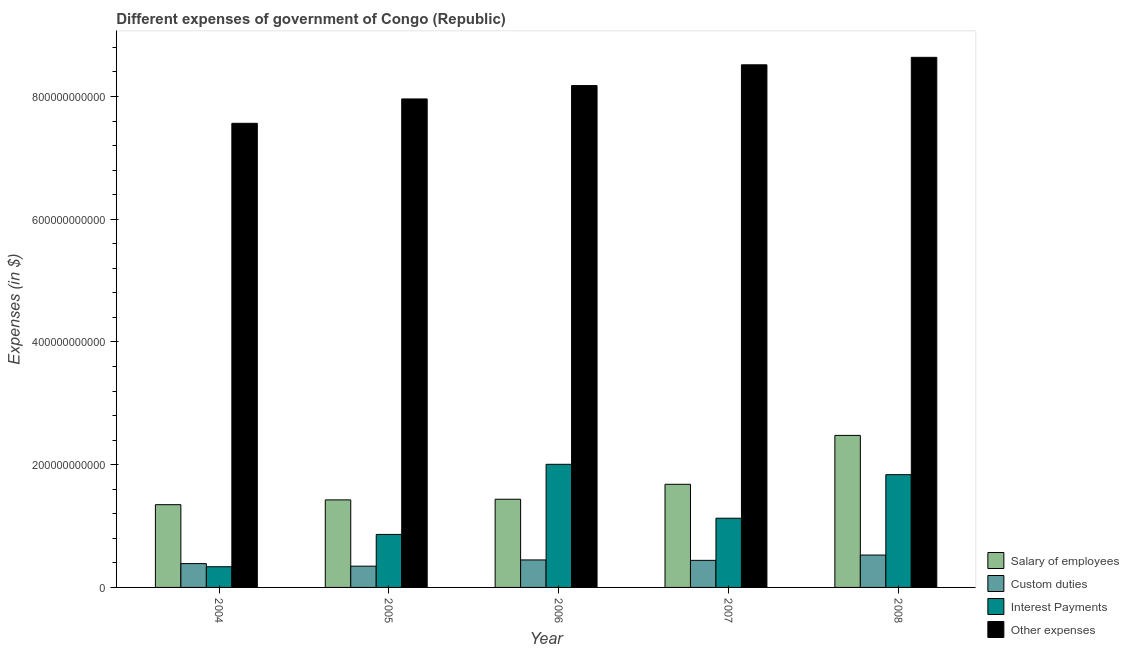How many different coloured bars are there?
Keep it short and to the point. 4. Are the number of bars on each tick of the X-axis equal?
Provide a short and direct response. Yes. How many bars are there on the 1st tick from the right?
Offer a very short reply. 4. In how many cases, is the number of bars for a given year not equal to the number of legend labels?
Offer a terse response. 0. What is the amount spent on interest payments in 2005?
Your answer should be compact. 8.64e+1. Across all years, what is the maximum amount spent on salary of employees?
Offer a very short reply. 2.48e+11. Across all years, what is the minimum amount spent on other expenses?
Your answer should be compact. 7.56e+11. What is the total amount spent on salary of employees in the graph?
Ensure brevity in your answer.  8.37e+11. What is the difference between the amount spent on interest payments in 2004 and that in 2008?
Your answer should be very brief. -1.50e+11. What is the difference between the amount spent on custom duties in 2004 and the amount spent on interest payments in 2007?
Make the answer very short. -5.30e+09. What is the average amount spent on salary of employees per year?
Your answer should be very brief. 1.67e+11. In the year 2008, what is the difference between the amount spent on salary of employees and amount spent on interest payments?
Make the answer very short. 0. In how many years, is the amount spent on custom duties greater than 480000000000 $?
Provide a short and direct response. 0. What is the ratio of the amount spent on interest payments in 2004 to that in 2006?
Provide a succinct answer. 0.17. Is the amount spent on salary of employees in 2005 less than that in 2008?
Your answer should be very brief. Yes. What is the difference between the highest and the second highest amount spent on interest payments?
Provide a succinct answer. 1.69e+1. What is the difference between the highest and the lowest amount spent on salary of employees?
Give a very brief answer. 1.13e+11. In how many years, is the amount spent on other expenses greater than the average amount spent on other expenses taken over all years?
Make the answer very short. 3. Is the sum of the amount spent on other expenses in 2004 and 2008 greater than the maximum amount spent on salary of employees across all years?
Keep it short and to the point. Yes. What does the 2nd bar from the left in 2007 represents?
Your answer should be very brief. Custom duties. What does the 4th bar from the right in 2007 represents?
Your answer should be compact. Salary of employees. How many bars are there?
Your answer should be compact. 20. Are all the bars in the graph horizontal?
Provide a short and direct response. No. How many years are there in the graph?
Keep it short and to the point. 5. What is the difference between two consecutive major ticks on the Y-axis?
Keep it short and to the point. 2.00e+11. Are the values on the major ticks of Y-axis written in scientific E-notation?
Make the answer very short. No. Does the graph contain any zero values?
Provide a short and direct response. No. Does the graph contain grids?
Give a very brief answer. No. How are the legend labels stacked?
Your answer should be very brief. Vertical. What is the title of the graph?
Make the answer very short. Different expenses of government of Congo (Republic). Does "Structural Policies" appear as one of the legend labels in the graph?
Make the answer very short. No. What is the label or title of the Y-axis?
Your response must be concise. Expenses (in $). What is the Expenses (in $) in Salary of employees in 2004?
Your answer should be very brief. 1.35e+11. What is the Expenses (in $) in Custom duties in 2004?
Provide a short and direct response. 3.88e+1. What is the Expenses (in $) in Interest Payments in 2004?
Keep it short and to the point. 3.37e+1. What is the Expenses (in $) of Other expenses in 2004?
Give a very brief answer. 7.56e+11. What is the Expenses (in $) in Salary of employees in 2005?
Ensure brevity in your answer.  1.43e+11. What is the Expenses (in $) in Custom duties in 2005?
Your answer should be compact. 3.46e+1. What is the Expenses (in $) of Interest Payments in 2005?
Provide a short and direct response. 8.64e+1. What is the Expenses (in $) of Other expenses in 2005?
Ensure brevity in your answer.  7.96e+11. What is the Expenses (in $) in Salary of employees in 2006?
Make the answer very short. 1.44e+11. What is the Expenses (in $) of Custom duties in 2006?
Keep it short and to the point. 4.48e+1. What is the Expenses (in $) in Interest Payments in 2006?
Offer a very short reply. 2.01e+11. What is the Expenses (in $) in Other expenses in 2006?
Your answer should be compact. 8.18e+11. What is the Expenses (in $) in Salary of employees in 2007?
Ensure brevity in your answer.  1.68e+11. What is the Expenses (in $) of Custom duties in 2007?
Provide a succinct answer. 4.41e+1. What is the Expenses (in $) in Interest Payments in 2007?
Offer a very short reply. 1.13e+11. What is the Expenses (in $) in Other expenses in 2007?
Give a very brief answer. 8.52e+11. What is the Expenses (in $) in Salary of employees in 2008?
Ensure brevity in your answer.  2.48e+11. What is the Expenses (in $) of Custom duties in 2008?
Offer a very short reply. 5.27e+1. What is the Expenses (in $) in Interest Payments in 2008?
Provide a succinct answer. 1.84e+11. What is the Expenses (in $) of Other expenses in 2008?
Offer a very short reply. 8.64e+11. Across all years, what is the maximum Expenses (in $) of Salary of employees?
Provide a succinct answer. 2.48e+11. Across all years, what is the maximum Expenses (in $) of Custom duties?
Your answer should be compact. 5.27e+1. Across all years, what is the maximum Expenses (in $) in Interest Payments?
Make the answer very short. 2.01e+11. Across all years, what is the maximum Expenses (in $) in Other expenses?
Make the answer very short. 8.64e+11. Across all years, what is the minimum Expenses (in $) in Salary of employees?
Keep it short and to the point. 1.35e+11. Across all years, what is the minimum Expenses (in $) in Custom duties?
Provide a succinct answer. 3.46e+1. Across all years, what is the minimum Expenses (in $) of Interest Payments?
Offer a very short reply. 3.37e+1. Across all years, what is the minimum Expenses (in $) of Other expenses?
Keep it short and to the point. 7.56e+11. What is the total Expenses (in $) in Salary of employees in the graph?
Ensure brevity in your answer.  8.37e+11. What is the total Expenses (in $) of Custom duties in the graph?
Your answer should be very brief. 2.15e+11. What is the total Expenses (in $) of Interest Payments in the graph?
Keep it short and to the point. 6.17e+11. What is the total Expenses (in $) of Other expenses in the graph?
Your answer should be very brief. 4.09e+12. What is the difference between the Expenses (in $) in Salary of employees in 2004 and that in 2005?
Offer a very short reply. -7.81e+09. What is the difference between the Expenses (in $) of Custom duties in 2004 and that in 2005?
Provide a short and direct response. 4.19e+09. What is the difference between the Expenses (in $) in Interest Payments in 2004 and that in 2005?
Your response must be concise. -5.27e+1. What is the difference between the Expenses (in $) in Other expenses in 2004 and that in 2005?
Offer a terse response. -3.97e+1. What is the difference between the Expenses (in $) in Salary of employees in 2004 and that in 2006?
Offer a terse response. -8.86e+09. What is the difference between the Expenses (in $) of Custom duties in 2004 and that in 2006?
Offer a terse response. -5.97e+09. What is the difference between the Expenses (in $) in Interest Payments in 2004 and that in 2006?
Your response must be concise. -1.67e+11. What is the difference between the Expenses (in $) of Other expenses in 2004 and that in 2006?
Your response must be concise. -6.15e+1. What is the difference between the Expenses (in $) in Salary of employees in 2004 and that in 2007?
Offer a very short reply. -3.32e+1. What is the difference between the Expenses (in $) of Custom duties in 2004 and that in 2007?
Your answer should be very brief. -5.30e+09. What is the difference between the Expenses (in $) of Interest Payments in 2004 and that in 2007?
Your answer should be compact. -7.90e+1. What is the difference between the Expenses (in $) of Other expenses in 2004 and that in 2007?
Provide a short and direct response. -9.53e+1. What is the difference between the Expenses (in $) in Salary of employees in 2004 and that in 2008?
Your answer should be very brief. -1.13e+11. What is the difference between the Expenses (in $) of Custom duties in 2004 and that in 2008?
Ensure brevity in your answer.  -1.39e+1. What is the difference between the Expenses (in $) in Interest Payments in 2004 and that in 2008?
Your answer should be very brief. -1.50e+11. What is the difference between the Expenses (in $) of Other expenses in 2004 and that in 2008?
Keep it short and to the point. -1.08e+11. What is the difference between the Expenses (in $) in Salary of employees in 2005 and that in 2006?
Keep it short and to the point. -1.05e+09. What is the difference between the Expenses (in $) in Custom duties in 2005 and that in 2006?
Give a very brief answer. -1.02e+1. What is the difference between the Expenses (in $) in Interest Payments in 2005 and that in 2006?
Make the answer very short. -1.14e+11. What is the difference between the Expenses (in $) of Other expenses in 2005 and that in 2006?
Give a very brief answer. -2.18e+1. What is the difference between the Expenses (in $) in Salary of employees in 2005 and that in 2007?
Provide a succinct answer. -2.54e+1. What is the difference between the Expenses (in $) of Custom duties in 2005 and that in 2007?
Give a very brief answer. -9.48e+09. What is the difference between the Expenses (in $) in Interest Payments in 2005 and that in 2007?
Make the answer very short. -2.64e+1. What is the difference between the Expenses (in $) in Other expenses in 2005 and that in 2007?
Offer a very short reply. -5.56e+1. What is the difference between the Expenses (in $) in Salary of employees in 2005 and that in 2008?
Give a very brief answer. -1.05e+11. What is the difference between the Expenses (in $) of Custom duties in 2005 and that in 2008?
Ensure brevity in your answer.  -1.81e+1. What is the difference between the Expenses (in $) in Interest Payments in 2005 and that in 2008?
Provide a succinct answer. -9.73e+1. What is the difference between the Expenses (in $) of Other expenses in 2005 and that in 2008?
Ensure brevity in your answer.  -6.78e+1. What is the difference between the Expenses (in $) of Salary of employees in 2006 and that in 2007?
Ensure brevity in your answer.  -2.43e+1. What is the difference between the Expenses (in $) of Custom duties in 2006 and that in 2007?
Ensure brevity in your answer.  6.73e+08. What is the difference between the Expenses (in $) of Interest Payments in 2006 and that in 2007?
Provide a succinct answer. 8.79e+1. What is the difference between the Expenses (in $) of Other expenses in 2006 and that in 2007?
Make the answer very short. -3.38e+1. What is the difference between the Expenses (in $) in Salary of employees in 2006 and that in 2008?
Your answer should be very brief. -1.04e+11. What is the difference between the Expenses (in $) of Custom duties in 2006 and that in 2008?
Offer a very short reply. -7.95e+09. What is the difference between the Expenses (in $) of Interest Payments in 2006 and that in 2008?
Give a very brief answer. 1.69e+1. What is the difference between the Expenses (in $) in Other expenses in 2006 and that in 2008?
Keep it short and to the point. -4.60e+1. What is the difference between the Expenses (in $) of Salary of employees in 2007 and that in 2008?
Give a very brief answer. -7.97e+1. What is the difference between the Expenses (in $) of Custom duties in 2007 and that in 2008?
Give a very brief answer. -8.62e+09. What is the difference between the Expenses (in $) of Interest Payments in 2007 and that in 2008?
Your answer should be very brief. -7.10e+1. What is the difference between the Expenses (in $) in Other expenses in 2007 and that in 2008?
Ensure brevity in your answer.  -1.22e+1. What is the difference between the Expenses (in $) of Salary of employees in 2004 and the Expenses (in $) of Custom duties in 2005?
Ensure brevity in your answer.  1.00e+11. What is the difference between the Expenses (in $) of Salary of employees in 2004 and the Expenses (in $) of Interest Payments in 2005?
Provide a short and direct response. 4.85e+1. What is the difference between the Expenses (in $) in Salary of employees in 2004 and the Expenses (in $) in Other expenses in 2005?
Your answer should be very brief. -6.61e+11. What is the difference between the Expenses (in $) of Custom duties in 2004 and the Expenses (in $) of Interest Payments in 2005?
Make the answer very short. -4.76e+1. What is the difference between the Expenses (in $) of Custom duties in 2004 and the Expenses (in $) of Other expenses in 2005?
Provide a succinct answer. -7.57e+11. What is the difference between the Expenses (in $) in Interest Payments in 2004 and the Expenses (in $) in Other expenses in 2005?
Provide a succinct answer. -7.62e+11. What is the difference between the Expenses (in $) of Salary of employees in 2004 and the Expenses (in $) of Custom duties in 2006?
Your response must be concise. 9.00e+1. What is the difference between the Expenses (in $) of Salary of employees in 2004 and the Expenses (in $) of Interest Payments in 2006?
Provide a succinct answer. -6.58e+1. What is the difference between the Expenses (in $) of Salary of employees in 2004 and the Expenses (in $) of Other expenses in 2006?
Offer a terse response. -6.83e+11. What is the difference between the Expenses (in $) of Custom duties in 2004 and the Expenses (in $) of Interest Payments in 2006?
Your answer should be very brief. -1.62e+11. What is the difference between the Expenses (in $) of Custom duties in 2004 and the Expenses (in $) of Other expenses in 2006?
Provide a short and direct response. -7.79e+11. What is the difference between the Expenses (in $) in Interest Payments in 2004 and the Expenses (in $) in Other expenses in 2006?
Offer a very short reply. -7.84e+11. What is the difference between the Expenses (in $) of Salary of employees in 2004 and the Expenses (in $) of Custom duties in 2007?
Your response must be concise. 9.07e+1. What is the difference between the Expenses (in $) of Salary of employees in 2004 and the Expenses (in $) of Interest Payments in 2007?
Your answer should be compact. 2.21e+1. What is the difference between the Expenses (in $) in Salary of employees in 2004 and the Expenses (in $) in Other expenses in 2007?
Provide a succinct answer. -7.17e+11. What is the difference between the Expenses (in $) in Custom duties in 2004 and the Expenses (in $) in Interest Payments in 2007?
Offer a terse response. -7.39e+1. What is the difference between the Expenses (in $) of Custom duties in 2004 and the Expenses (in $) of Other expenses in 2007?
Keep it short and to the point. -8.13e+11. What is the difference between the Expenses (in $) of Interest Payments in 2004 and the Expenses (in $) of Other expenses in 2007?
Your answer should be compact. -8.18e+11. What is the difference between the Expenses (in $) of Salary of employees in 2004 and the Expenses (in $) of Custom duties in 2008?
Offer a terse response. 8.21e+1. What is the difference between the Expenses (in $) of Salary of employees in 2004 and the Expenses (in $) of Interest Payments in 2008?
Provide a short and direct response. -4.89e+1. What is the difference between the Expenses (in $) in Salary of employees in 2004 and the Expenses (in $) in Other expenses in 2008?
Your answer should be compact. -7.29e+11. What is the difference between the Expenses (in $) in Custom duties in 2004 and the Expenses (in $) in Interest Payments in 2008?
Provide a short and direct response. -1.45e+11. What is the difference between the Expenses (in $) of Custom duties in 2004 and the Expenses (in $) of Other expenses in 2008?
Your answer should be very brief. -8.25e+11. What is the difference between the Expenses (in $) in Interest Payments in 2004 and the Expenses (in $) in Other expenses in 2008?
Offer a very short reply. -8.30e+11. What is the difference between the Expenses (in $) in Salary of employees in 2005 and the Expenses (in $) in Custom duties in 2006?
Your response must be concise. 9.78e+1. What is the difference between the Expenses (in $) of Salary of employees in 2005 and the Expenses (in $) of Interest Payments in 2006?
Your response must be concise. -5.80e+1. What is the difference between the Expenses (in $) in Salary of employees in 2005 and the Expenses (in $) in Other expenses in 2006?
Provide a succinct answer. -6.75e+11. What is the difference between the Expenses (in $) in Custom duties in 2005 and the Expenses (in $) in Interest Payments in 2006?
Ensure brevity in your answer.  -1.66e+11. What is the difference between the Expenses (in $) in Custom duties in 2005 and the Expenses (in $) in Other expenses in 2006?
Give a very brief answer. -7.83e+11. What is the difference between the Expenses (in $) of Interest Payments in 2005 and the Expenses (in $) of Other expenses in 2006?
Your response must be concise. -7.31e+11. What is the difference between the Expenses (in $) of Salary of employees in 2005 and the Expenses (in $) of Custom duties in 2007?
Provide a short and direct response. 9.85e+1. What is the difference between the Expenses (in $) in Salary of employees in 2005 and the Expenses (in $) in Interest Payments in 2007?
Make the answer very short. 2.99e+1. What is the difference between the Expenses (in $) in Salary of employees in 2005 and the Expenses (in $) in Other expenses in 2007?
Offer a very short reply. -7.09e+11. What is the difference between the Expenses (in $) in Custom duties in 2005 and the Expenses (in $) in Interest Payments in 2007?
Keep it short and to the point. -7.81e+1. What is the difference between the Expenses (in $) of Custom duties in 2005 and the Expenses (in $) of Other expenses in 2007?
Offer a terse response. -8.17e+11. What is the difference between the Expenses (in $) of Interest Payments in 2005 and the Expenses (in $) of Other expenses in 2007?
Provide a short and direct response. -7.65e+11. What is the difference between the Expenses (in $) of Salary of employees in 2005 and the Expenses (in $) of Custom duties in 2008?
Your answer should be compact. 8.99e+1. What is the difference between the Expenses (in $) of Salary of employees in 2005 and the Expenses (in $) of Interest Payments in 2008?
Offer a terse response. -4.11e+1. What is the difference between the Expenses (in $) of Salary of employees in 2005 and the Expenses (in $) of Other expenses in 2008?
Your response must be concise. -7.21e+11. What is the difference between the Expenses (in $) of Custom duties in 2005 and the Expenses (in $) of Interest Payments in 2008?
Provide a succinct answer. -1.49e+11. What is the difference between the Expenses (in $) of Custom duties in 2005 and the Expenses (in $) of Other expenses in 2008?
Provide a short and direct response. -8.29e+11. What is the difference between the Expenses (in $) of Interest Payments in 2005 and the Expenses (in $) of Other expenses in 2008?
Give a very brief answer. -7.77e+11. What is the difference between the Expenses (in $) in Salary of employees in 2006 and the Expenses (in $) in Custom duties in 2007?
Provide a succinct answer. 9.96e+1. What is the difference between the Expenses (in $) of Salary of employees in 2006 and the Expenses (in $) of Interest Payments in 2007?
Make the answer very short. 3.09e+1. What is the difference between the Expenses (in $) of Salary of employees in 2006 and the Expenses (in $) of Other expenses in 2007?
Ensure brevity in your answer.  -7.08e+11. What is the difference between the Expenses (in $) in Custom duties in 2006 and the Expenses (in $) in Interest Payments in 2007?
Offer a terse response. -6.80e+1. What is the difference between the Expenses (in $) of Custom duties in 2006 and the Expenses (in $) of Other expenses in 2007?
Provide a succinct answer. -8.07e+11. What is the difference between the Expenses (in $) of Interest Payments in 2006 and the Expenses (in $) of Other expenses in 2007?
Provide a short and direct response. -6.51e+11. What is the difference between the Expenses (in $) of Salary of employees in 2006 and the Expenses (in $) of Custom duties in 2008?
Your answer should be very brief. 9.10e+1. What is the difference between the Expenses (in $) in Salary of employees in 2006 and the Expenses (in $) in Interest Payments in 2008?
Your response must be concise. -4.00e+1. What is the difference between the Expenses (in $) of Salary of employees in 2006 and the Expenses (in $) of Other expenses in 2008?
Your response must be concise. -7.20e+11. What is the difference between the Expenses (in $) of Custom duties in 2006 and the Expenses (in $) of Interest Payments in 2008?
Your response must be concise. -1.39e+11. What is the difference between the Expenses (in $) of Custom duties in 2006 and the Expenses (in $) of Other expenses in 2008?
Make the answer very short. -8.19e+11. What is the difference between the Expenses (in $) of Interest Payments in 2006 and the Expenses (in $) of Other expenses in 2008?
Make the answer very short. -6.63e+11. What is the difference between the Expenses (in $) in Salary of employees in 2007 and the Expenses (in $) in Custom duties in 2008?
Your answer should be compact. 1.15e+11. What is the difference between the Expenses (in $) of Salary of employees in 2007 and the Expenses (in $) of Interest Payments in 2008?
Your response must be concise. -1.57e+1. What is the difference between the Expenses (in $) of Salary of employees in 2007 and the Expenses (in $) of Other expenses in 2008?
Ensure brevity in your answer.  -6.96e+11. What is the difference between the Expenses (in $) of Custom duties in 2007 and the Expenses (in $) of Interest Payments in 2008?
Make the answer very short. -1.40e+11. What is the difference between the Expenses (in $) in Custom duties in 2007 and the Expenses (in $) in Other expenses in 2008?
Ensure brevity in your answer.  -8.20e+11. What is the difference between the Expenses (in $) in Interest Payments in 2007 and the Expenses (in $) in Other expenses in 2008?
Make the answer very short. -7.51e+11. What is the average Expenses (in $) of Salary of employees per year?
Give a very brief answer. 1.67e+11. What is the average Expenses (in $) of Custom duties per year?
Offer a terse response. 4.30e+1. What is the average Expenses (in $) in Interest Payments per year?
Offer a very short reply. 1.23e+11. What is the average Expenses (in $) of Other expenses per year?
Your answer should be very brief. 8.17e+11. In the year 2004, what is the difference between the Expenses (in $) of Salary of employees and Expenses (in $) of Custom duties?
Provide a succinct answer. 9.60e+1. In the year 2004, what is the difference between the Expenses (in $) of Salary of employees and Expenses (in $) of Interest Payments?
Provide a short and direct response. 1.01e+11. In the year 2004, what is the difference between the Expenses (in $) of Salary of employees and Expenses (in $) of Other expenses?
Provide a succinct answer. -6.21e+11. In the year 2004, what is the difference between the Expenses (in $) of Custom duties and Expenses (in $) of Interest Payments?
Give a very brief answer. 5.10e+09. In the year 2004, what is the difference between the Expenses (in $) of Custom duties and Expenses (in $) of Other expenses?
Your answer should be very brief. -7.17e+11. In the year 2004, what is the difference between the Expenses (in $) in Interest Payments and Expenses (in $) in Other expenses?
Ensure brevity in your answer.  -7.23e+11. In the year 2005, what is the difference between the Expenses (in $) in Salary of employees and Expenses (in $) in Custom duties?
Keep it short and to the point. 1.08e+11. In the year 2005, what is the difference between the Expenses (in $) in Salary of employees and Expenses (in $) in Interest Payments?
Provide a short and direct response. 5.63e+1. In the year 2005, what is the difference between the Expenses (in $) in Salary of employees and Expenses (in $) in Other expenses?
Offer a very short reply. -6.53e+11. In the year 2005, what is the difference between the Expenses (in $) of Custom duties and Expenses (in $) of Interest Payments?
Your response must be concise. -5.17e+1. In the year 2005, what is the difference between the Expenses (in $) in Custom duties and Expenses (in $) in Other expenses?
Keep it short and to the point. -7.61e+11. In the year 2005, what is the difference between the Expenses (in $) in Interest Payments and Expenses (in $) in Other expenses?
Offer a very short reply. -7.10e+11. In the year 2006, what is the difference between the Expenses (in $) of Salary of employees and Expenses (in $) of Custom duties?
Keep it short and to the point. 9.89e+1. In the year 2006, what is the difference between the Expenses (in $) of Salary of employees and Expenses (in $) of Interest Payments?
Keep it short and to the point. -5.69e+1. In the year 2006, what is the difference between the Expenses (in $) of Salary of employees and Expenses (in $) of Other expenses?
Offer a very short reply. -6.74e+11. In the year 2006, what is the difference between the Expenses (in $) in Custom duties and Expenses (in $) in Interest Payments?
Give a very brief answer. -1.56e+11. In the year 2006, what is the difference between the Expenses (in $) of Custom duties and Expenses (in $) of Other expenses?
Provide a short and direct response. -7.73e+11. In the year 2006, what is the difference between the Expenses (in $) in Interest Payments and Expenses (in $) in Other expenses?
Your answer should be very brief. -6.17e+11. In the year 2007, what is the difference between the Expenses (in $) in Salary of employees and Expenses (in $) in Custom duties?
Offer a very short reply. 1.24e+11. In the year 2007, what is the difference between the Expenses (in $) in Salary of employees and Expenses (in $) in Interest Payments?
Your response must be concise. 5.53e+1. In the year 2007, what is the difference between the Expenses (in $) of Salary of employees and Expenses (in $) of Other expenses?
Provide a short and direct response. -6.84e+11. In the year 2007, what is the difference between the Expenses (in $) in Custom duties and Expenses (in $) in Interest Payments?
Provide a short and direct response. -6.86e+1. In the year 2007, what is the difference between the Expenses (in $) in Custom duties and Expenses (in $) in Other expenses?
Provide a short and direct response. -8.07e+11. In the year 2007, what is the difference between the Expenses (in $) of Interest Payments and Expenses (in $) of Other expenses?
Make the answer very short. -7.39e+11. In the year 2008, what is the difference between the Expenses (in $) of Salary of employees and Expenses (in $) of Custom duties?
Your answer should be very brief. 1.95e+11. In the year 2008, what is the difference between the Expenses (in $) in Salary of employees and Expenses (in $) in Interest Payments?
Provide a succinct answer. 6.40e+1. In the year 2008, what is the difference between the Expenses (in $) in Salary of employees and Expenses (in $) in Other expenses?
Offer a very short reply. -6.16e+11. In the year 2008, what is the difference between the Expenses (in $) in Custom duties and Expenses (in $) in Interest Payments?
Your answer should be compact. -1.31e+11. In the year 2008, what is the difference between the Expenses (in $) of Custom duties and Expenses (in $) of Other expenses?
Provide a succinct answer. -8.11e+11. In the year 2008, what is the difference between the Expenses (in $) of Interest Payments and Expenses (in $) of Other expenses?
Provide a short and direct response. -6.80e+11. What is the ratio of the Expenses (in $) of Salary of employees in 2004 to that in 2005?
Ensure brevity in your answer.  0.95. What is the ratio of the Expenses (in $) of Custom duties in 2004 to that in 2005?
Make the answer very short. 1.12. What is the ratio of the Expenses (in $) of Interest Payments in 2004 to that in 2005?
Keep it short and to the point. 0.39. What is the ratio of the Expenses (in $) in Other expenses in 2004 to that in 2005?
Keep it short and to the point. 0.95. What is the ratio of the Expenses (in $) of Salary of employees in 2004 to that in 2006?
Your response must be concise. 0.94. What is the ratio of the Expenses (in $) in Custom duties in 2004 to that in 2006?
Keep it short and to the point. 0.87. What is the ratio of the Expenses (in $) in Interest Payments in 2004 to that in 2006?
Ensure brevity in your answer.  0.17. What is the ratio of the Expenses (in $) of Other expenses in 2004 to that in 2006?
Give a very brief answer. 0.92. What is the ratio of the Expenses (in $) in Salary of employees in 2004 to that in 2007?
Make the answer very short. 0.8. What is the ratio of the Expenses (in $) in Custom duties in 2004 to that in 2007?
Your answer should be compact. 0.88. What is the ratio of the Expenses (in $) in Interest Payments in 2004 to that in 2007?
Provide a succinct answer. 0.3. What is the ratio of the Expenses (in $) of Other expenses in 2004 to that in 2007?
Give a very brief answer. 0.89. What is the ratio of the Expenses (in $) in Salary of employees in 2004 to that in 2008?
Ensure brevity in your answer.  0.54. What is the ratio of the Expenses (in $) in Custom duties in 2004 to that in 2008?
Your response must be concise. 0.74. What is the ratio of the Expenses (in $) in Interest Payments in 2004 to that in 2008?
Give a very brief answer. 0.18. What is the ratio of the Expenses (in $) of Other expenses in 2004 to that in 2008?
Offer a very short reply. 0.88. What is the ratio of the Expenses (in $) in Custom duties in 2005 to that in 2006?
Offer a very short reply. 0.77. What is the ratio of the Expenses (in $) of Interest Payments in 2005 to that in 2006?
Ensure brevity in your answer.  0.43. What is the ratio of the Expenses (in $) of Other expenses in 2005 to that in 2006?
Provide a succinct answer. 0.97. What is the ratio of the Expenses (in $) of Salary of employees in 2005 to that in 2007?
Make the answer very short. 0.85. What is the ratio of the Expenses (in $) of Custom duties in 2005 to that in 2007?
Give a very brief answer. 0.79. What is the ratio of the Expenses (in $) of Interest Payments in 2005 to that in 2007?
Provide a succinct answer. 0.77. What is the ratio of the Expenses (in $) of Other expenses in 2005 to that in 2007?
Ensure brevity in your answer.  0.93. What is the ratio of the Expenses (in $) of Salary of employees in 2005 to that in 2008?
Keep it short and to the point. 0.58. What is the ratio of the Expenses (in $) of Custom duties in 2005 to that in 2008?
Keep it short and to the point. 0.66. What is the ratio of the Expenses (in $) of Interest Payments in 2005 to that in 2008?
Your response must be concise. 0.47. What is the ratio of the Expenses (in $) in Other expenses in 2005 to that in 2008?
Your answer should be compact. 0.92. What is the ratio of the Expenses (in $) in Salary of employees in 2006 to that in 2007?
Offer a very short reply. 0.86. What is the ratio of the Expenses (in $) in Custom duties in 2006 to that in 2007?
Your response must be concise. 1.02. What is the ratio of the Expenses (in $) in Interest Payments in 2006 to that in 2007?
Keep it short and to the point. 1.78. What is the ratio of the Expenses (in $) of Other expenses in 2006 to that in 2007?
Provide a short and direct response. 0.96. What is the ratio of the Expenses (in $) in Salary of employees in 2006 to that in 2008?
Provide a succinct answer. 0.58. What is the ratio of the Expenses (in $) in Custom duties in 2006 to that in 2008?
Make the answer very short. 0.85. What is the ratio of the Expenses (in $) in Interest Payments in 2006 to that in 2008?
Your response must be concise. 1.09. What is the ratio of the Expenses (in $) of Other expenses in 2006 to that in 2008?
Your answer should be compact. 0.95. What is the ratio of the Expenses (in $) of Salary of employees in 2007 to that in 2008?
Provide a succinct answer. 0.68. What is the ratio of the Expenses (in $) in Custom duties in 2007 to that in 2008?
Provide a succinct answer. 0.84. What is the ratio of the Expenses (in $) of Interest Payments in 2007 to that in 2008?
Provide a short and direct response. 0.61. What is the ratio of the Expenses (in $) in Other expenses in 2007 to that in 2008?
Offer a terse response. 0.99. What is the difference between the highest and the second highest Expenses (in $) of Salary of employees?
Offer a terse response. 7.97e+1. What is the difference between the highest and the second highest Expenses (in $) of Custom duties?
Your response must be concise. 7.95e+09. What is the difference between the highest and the second highest Expenses (in $) of Interest Payments?
Your answer should be very brief. 1.69e+1. What is the difference between the highest and the second highest Expenses (in $) of Other expenses?
Your answer should be very brief. 1.22e+1. What is the difference between the highest and the lowest Expenses (in $) in Salary of employees?
Provide a short and direct response. 1.13e+11. What is the difference between the highest and the lowest Expenses (in $) of Custom duties?
Give a very brief answer. 1.81e+1. What is the difference between the highest and the lowest Expenses (in $) of Interest Payments?
Ensure brevity in your answer.  1.67e+11. What is the difference between the highest and the lowest Expenses (in $) in Other expenses?
Offer a very short reply. 1.08e+11. 